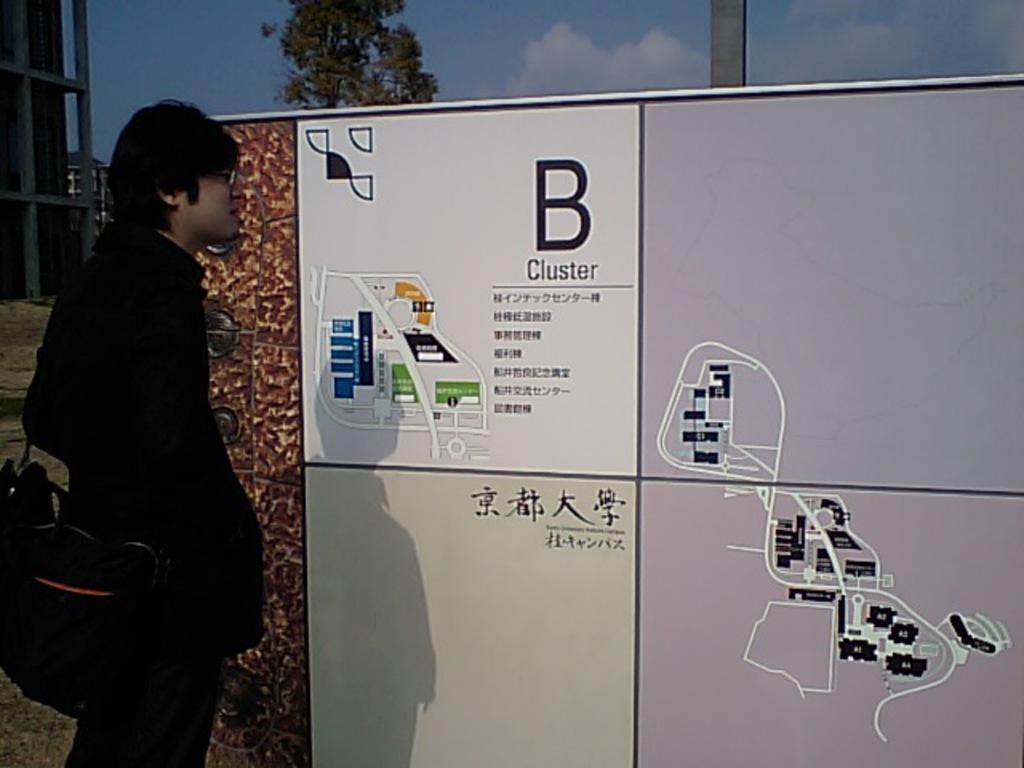How would you summarize this image in a sentence or two? In this image we can see a man is standing. He is wearing black color coat, pant and carrying black color bag. In front of him, one big board is there. On board maps are there. Background of the image we can see a tree, pole, building and the sky with clouds. 